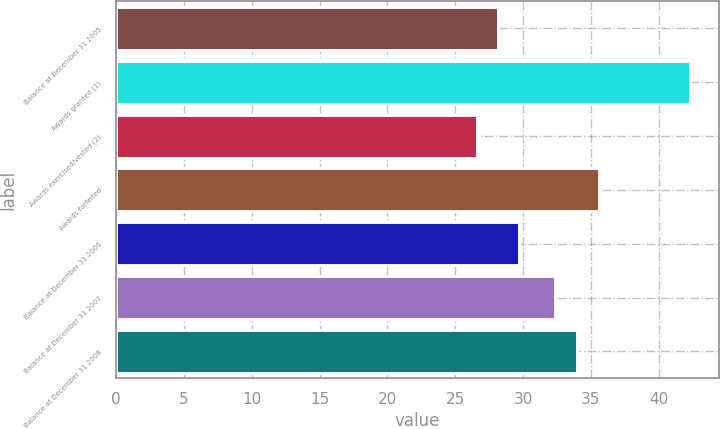<chart> <loc_0><loc_0><loc_500><loc_500><bar_chart><fcel>Balance at December 31 2005<fcel>Awards granted (1)<fcel>Awards exercised/vested (2)<fcel>Awards forfeited<fcel>Balance at December 31 2006<fcel>Balance at December 31 2007<fcel>Balance at December 31 2008<nl><fcel>28.15<fcel>42.32<fcel>26.58<fcel>35.57<fcel>29.72<fcel>32.37<fcel>33.94<nl></chart> 